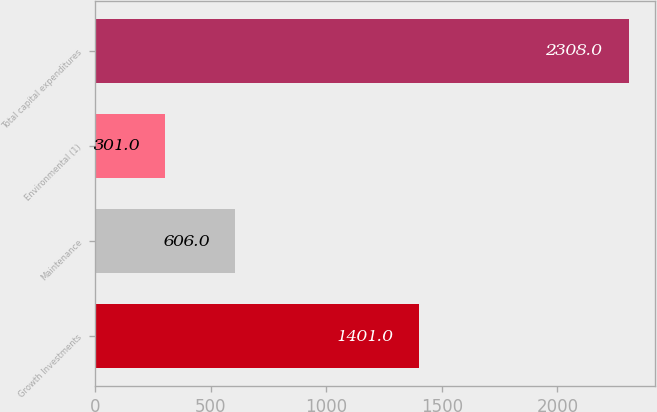Convert chart. <chart><loc_0><loc_0><loc_500><loc_500><bar_chart><fcel>Growth Investments<fcel>Maintenance<fcel>Environmental (1)<fcel>Total capital expenditures<nl><fcel>1401<fcel>606<fcel>301<fcel>2308<nl></chart> 